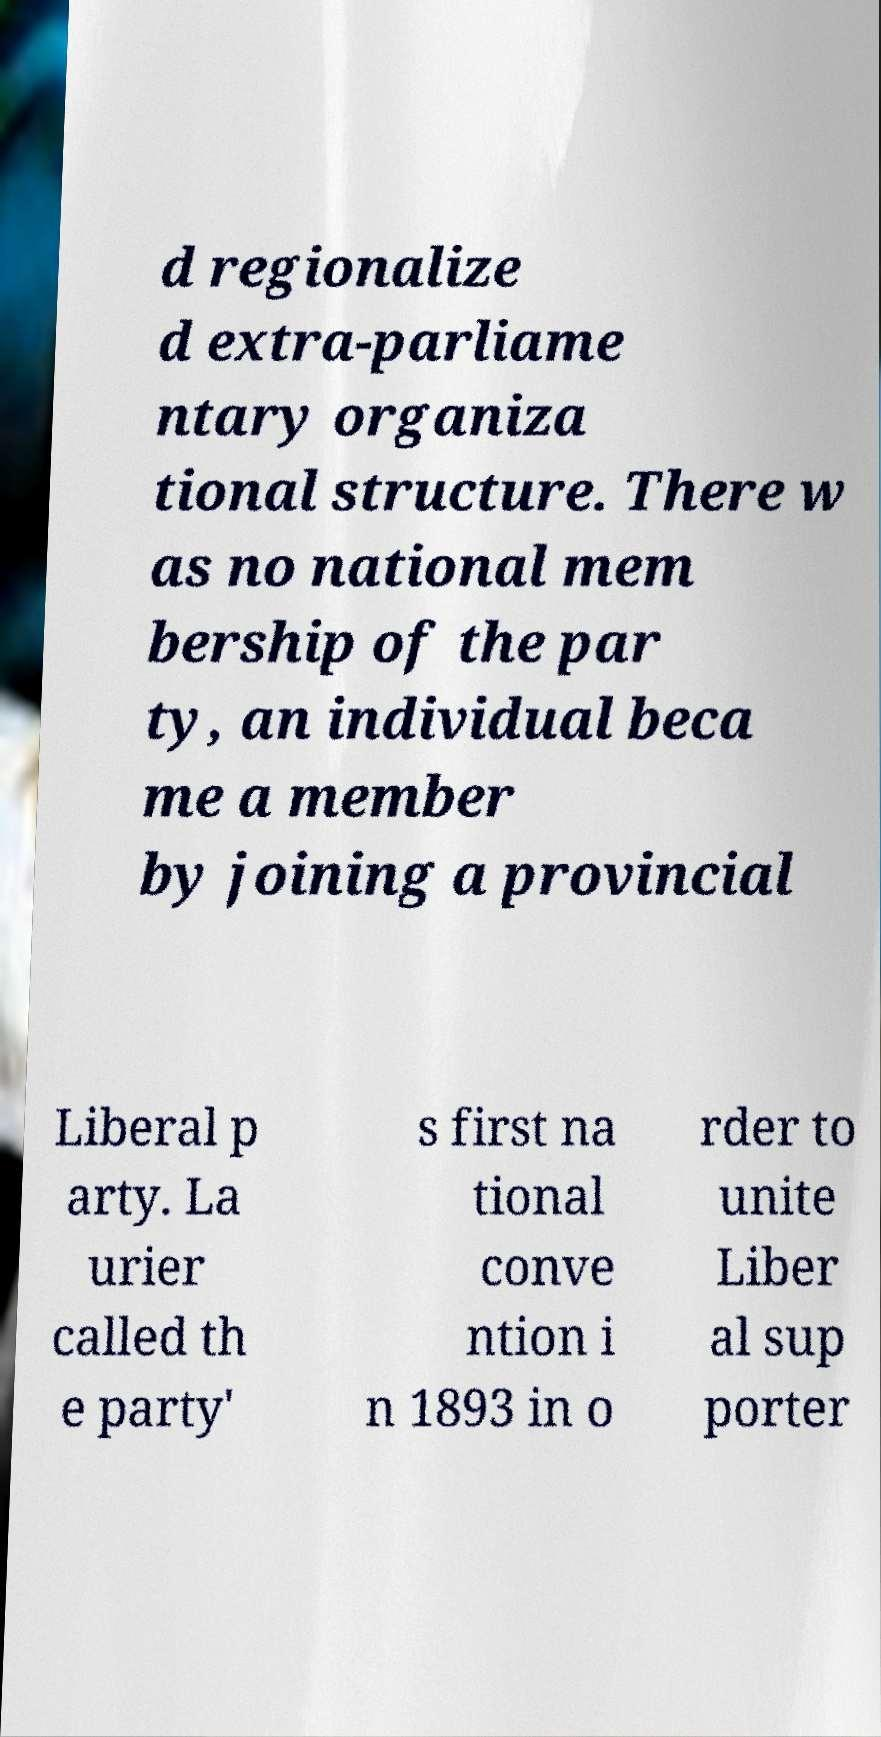Please read and relay the text visible in this image. What does it say? d regionalize d extra-parliame ntary organiza tional structure. There w as no national mem bership of the par ty, an individual beca me a member by joining a provincial Liberal p arty. La urier called th e party' s first na tional conve ntion i n 1893 in o rder to unite Liber al sup porter 